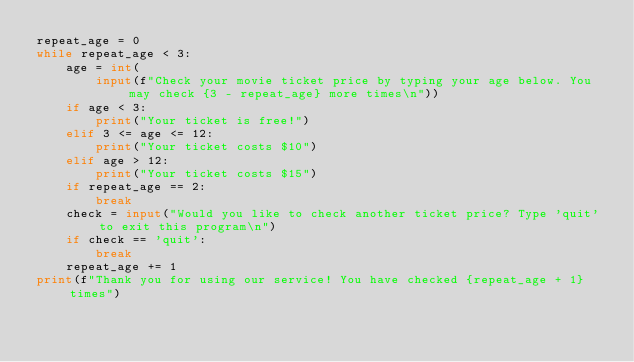<code> <loc_0><loc_0><loc_500><loc_500><_Python_>repeat_age = 0
while repeat_age < 3:
    age = int(
        input(f"Check your movie ticket price by typing your age below. You may check {3 - repeat_age} more times\n"))
    if age < 3:
        print("Your ticket is free!")
    elif 3 <= age <= 12:
        print("Your ticket costs $10")
    elif age > 12:
        print("Your ticket costs $15")
    if repeat_age == 2:
        break
    check = input("Would you like to check another ticket price? Type 'quit' to exit this program\n")
    if check == 'quit':
        break
    repeat_age += 1
print(f"Thank you for using our service! You have checked {repeat_age + 1} times")
</code> 